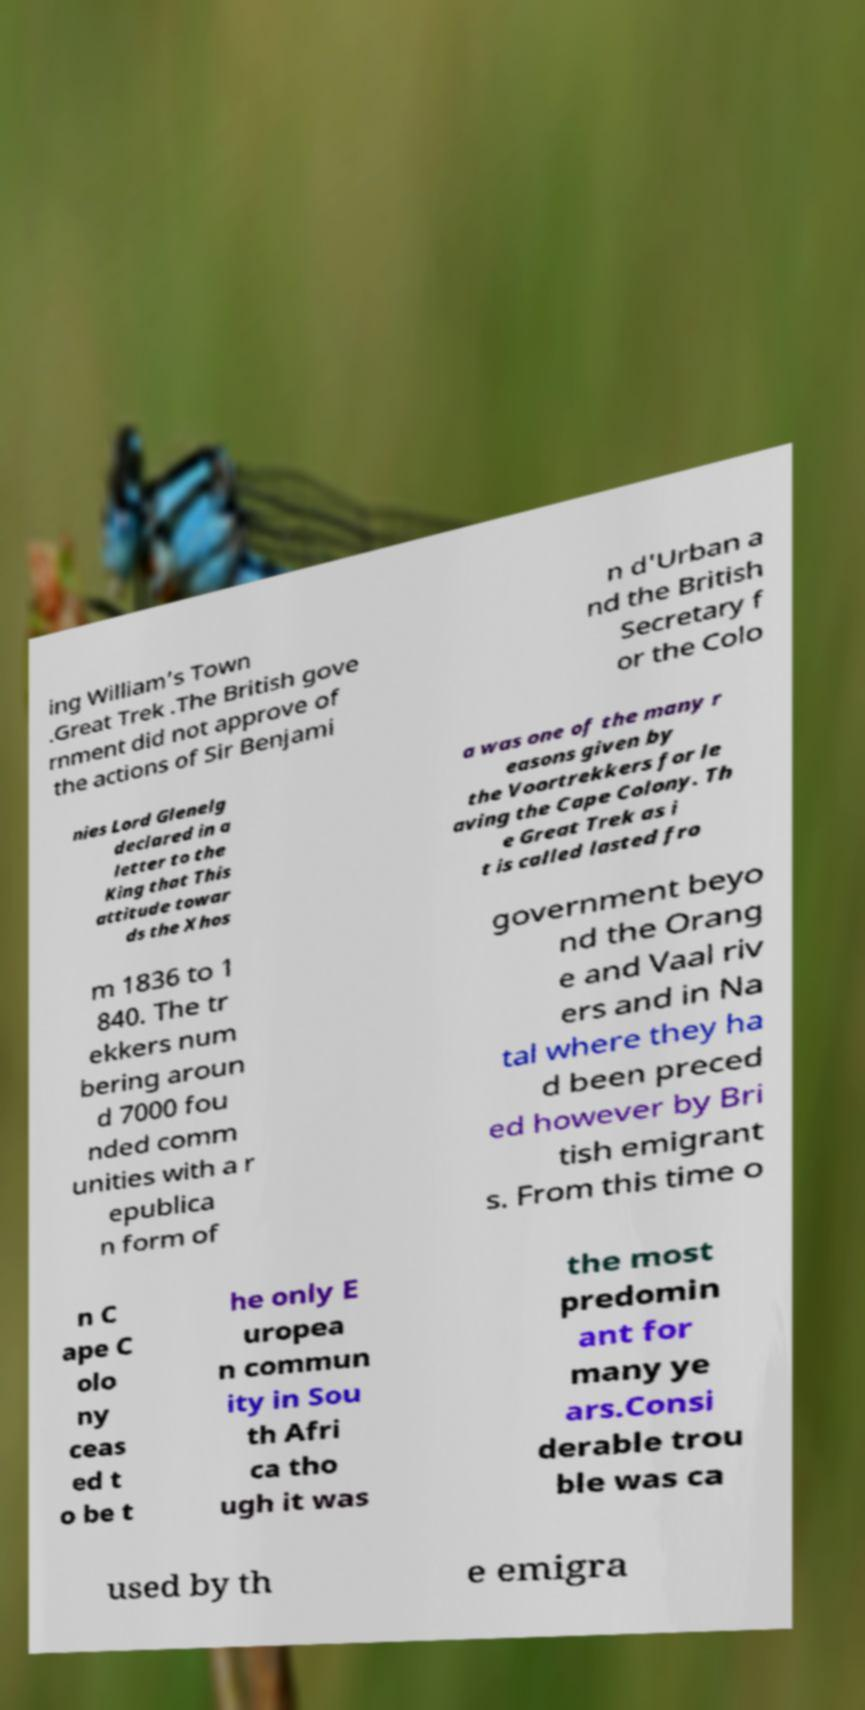Please read and relay the text visible in this image. What does it say? ing William’s Town .Great Trek .The British gove rnment did not approve of the actions of Sir Benjami n d'Urban a nd the British Secretary f or the Colo nies Lord Glenelg declared in a letter to the King that This attitude towar ds the Xhos a was one of the many r easons given by the Voortrekkers for le aving the Cape Colony. Th e Great Trek as i t is called lasted fro m 1836 to 1 840. The tr ekkers num bering aroun d 7000 fou nded comm unities with a r epublica n form of government beyo nd the Orang e and Vaal riv ers and in Na tal where they ha d been preced ed however by Bri tish emigrant s. From this time o n C ape C olo ny ceas ed t o be t he only E uropea n commun ity in Sou th Afri ca tho ugh it was the most predomin ant for many ye ars.Consi derable trou ble was ca used by th e emigra 